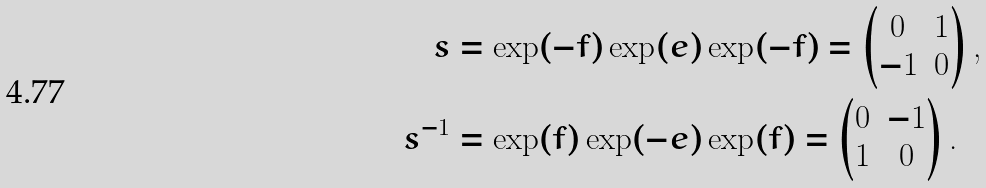<formula> <loc_0><loc_0><loc_500><loc_500>s & = \exp ( - f ) \exp ( e ) \exp ( - f ) = \begin{pmatrix} 0 & 1 \\ - 1 & 0 \end{pmatrix} , \\ s ^ { - 1 } & = \exp ( f ) \exp ( - e ) \exp ( f ) = \begin{pmatrix} 0 & - 1 \\ 1 & 0 \end{pmatrix} .</formula> 